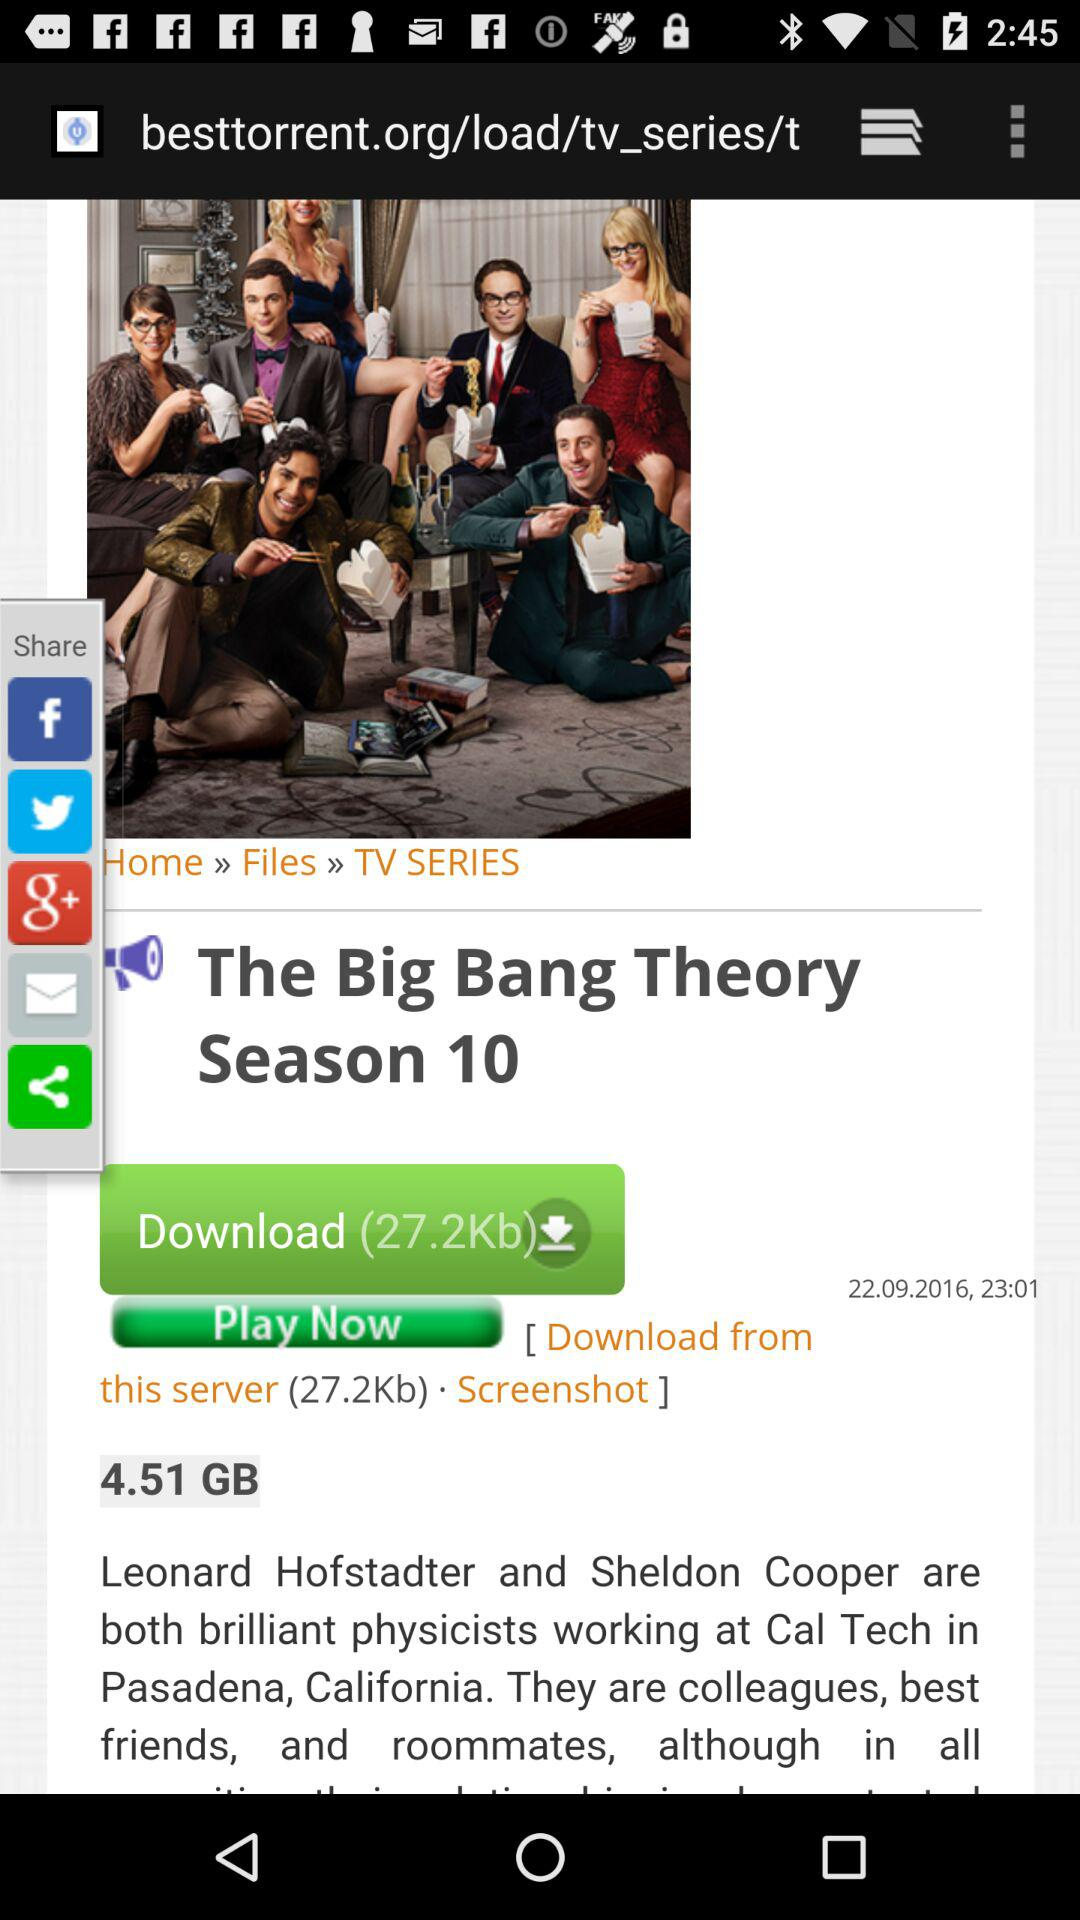What is the download size of "The Big Bang Theory Season 10"? The download size of "The Big Bang Theory Season 10" is 4.51 GB. 